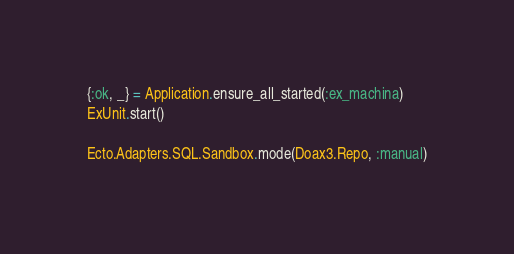Convert code to text. <code><loc_0><loc_0><loc_500><loc_500><_Elixir_>{:ok, _} = Application.ensure_all_started(:ex_machina)
ExUnit.start()

Ecto.Adapters.SQL.Sandbox.mode(Doax3.Repo, :manual)

</code> 